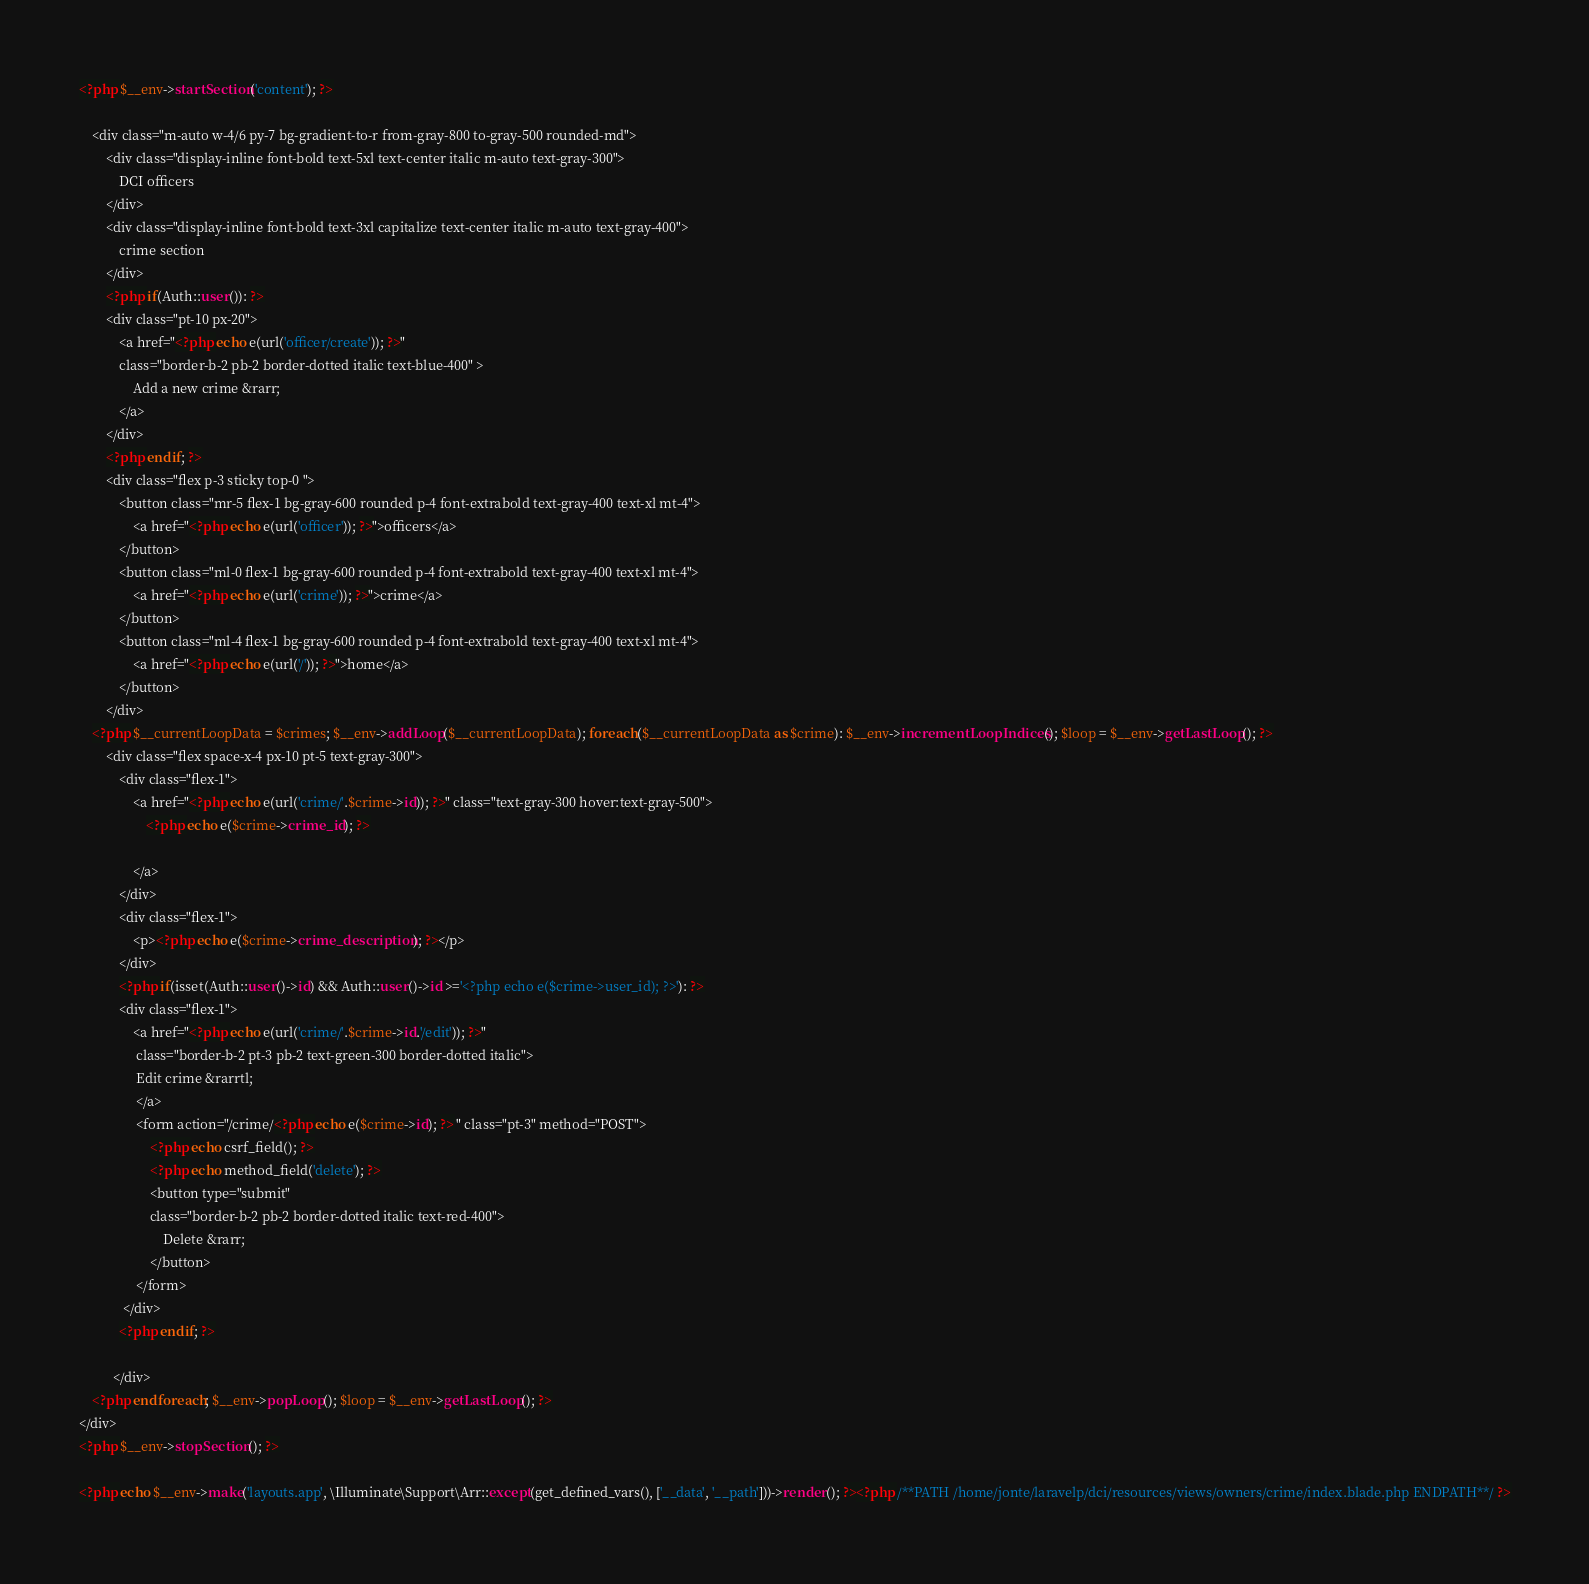Convert code to text. <code><loc_0><loc_0><loc_500><loc_500><_PHP_><?php $__env->startSection('content'); ?>

    <div class="m-auto w-4/6 py-7 bg-gradient-to-r from-gray-800 to-gray-500 rounded-md">
        <div class="display-inline font-bold text-5xl text-center italic m-auto text-gray-300">
            DCI officers
        </div>
        <div class="display-inline font-bold text-3xl capitalize text-center italic m-auto text-gray-400">
            crime section
        </div>
        <?php if(Auth::user()): ?>
        <div class="pt-10 px-20">
            <a href="<?php echo e(url('officer/create')); ?>"
            class="border-b-2 pb-2 border-dotted italic text-blue-400" >
                Add a new crime &rarr;
            </a>
        </div>
        <?php endif; ?>
        <div class="flex p-3 sticky top-0 ">
            <button class="mr-5 flex-1 bg-gray-600 rounded p-4 font-extrabold text-gray-400 text-xl mt-4">
                <a href="<?php echo e(url('officer')); ?>">officers</a>
            </button>
            <button class="ml-0 flex-1 bg-gray-600 rounded p-4 font-extrabold text-gray-400 text-xl mt-4">
                <a href="<?php echo e(url('crime')); ?>">crime</a>
            </button>
            <button class="ml-4 flex-1 bg-gray-600 rounded p-4 font-extrabold text-gray-400 text-xl mt-4">
                <a href="<?php echo e(url('/')); ?>">home</a>
            </button>
        </div>
    <?php $__currentLoopData = $crimes; $__env->addLoop($__currentLoopData); foreach($__currentLoopData as $crime): $__env->incrementLoopIndices(); $loop = $__env->getLastLoop(); ?>
        <div class="flex space-x-4 px-10 pt-5 text-gray-300">
            <div class="flex-1">
                <a href="<?php echo e(url('crime/'.$crime->id)); ?>" class="text-gray-300 hover:text-gray-500">
                    <?php echo e($crime->crime_id); ?>

                </a>
            </div>
            <div class="flex-1">
                <p><?php echo e($crime->crime_description); ?></p>
            </div>
            <?php if(isset(Auth::user()->id) && Auth::user()->id >='<?php echo e($crime->user_id); ?>'): ?>
            <div class="flex-1">
                <a href="<?php echo e(url('crime/'.$crime->id.'/edit')); ?>"
                 class="border-b-2 pt-3 pb-2 text-green-300 border-dotted italic">
                 Edit crime &rarrtl;
                 </a>
                 <form action="/crime/<?php echo e($crime->id); ?> " class="pt-3" method="POST">
                     <?php echo csrf_field(); ?>
                     <?php echo method_field('delete'); ?>
                     <button type="submit"
                     class="border-b-2 pb-2 border-dotted italic text-red-400">
                         Delete &rarr;
                     </button>
                 </form>
             </div>
            <?php endif; ?>

          </div>
    <?php endforeach; $__env->popLoop(); $loop = $__env->getLastLoop(); ?>
</div>
<?php $__env->stopSection(); ?>

<?php echo $__env->make('layouts.app', \Illuminate\Support\Arr::except(get_defined_vars(), ['__data', '__path']))->render(); ?><?php /**PATH /home/jonte/laravelp/dci/resources/views/owners/crime/index.blade.php ENDPATH**/ ?></code> 